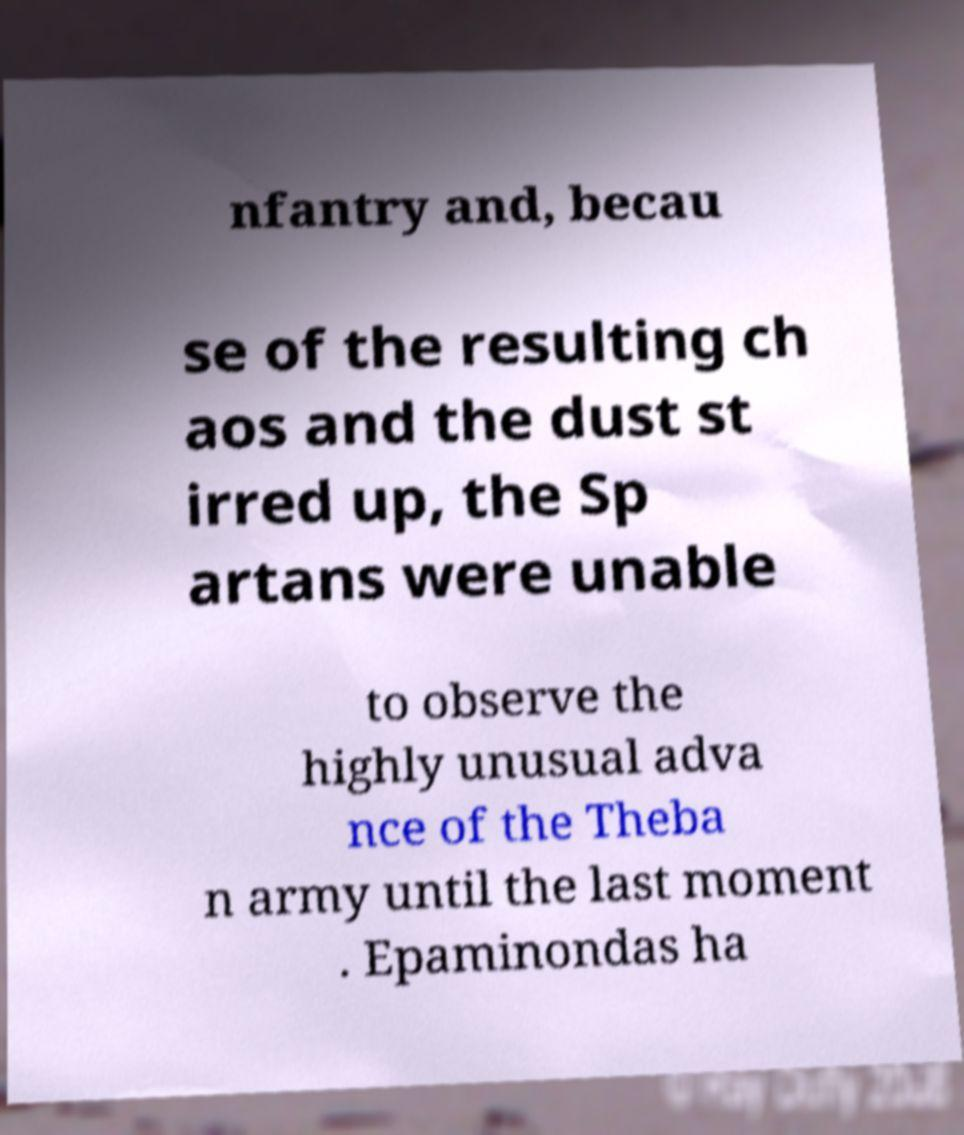I need the written content from this picture converted into text. Can you do that? nfantry and, becau se of the resulting ch aos and the dust st irred up, the Sp artans were unable to observe the highly unusual adva nce of the Theba n army until the last moment . Epaminondas ha 